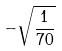<formula> <loc_0><loc_0><loc_500><loc_500>- \sqrt { \frac { 1 } { 7 0 } }</formula> 